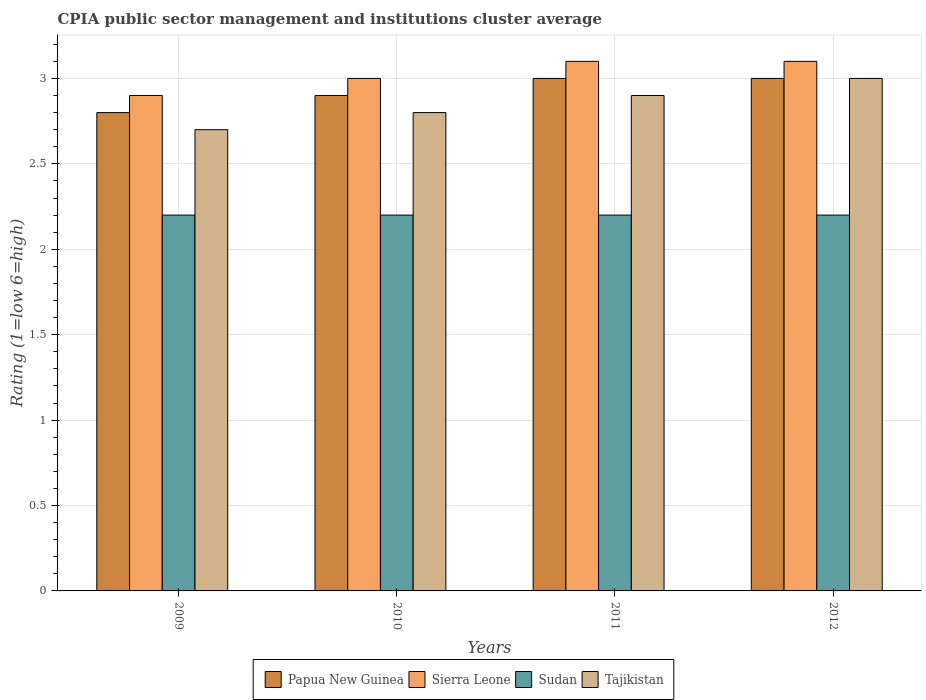Are the number of bars per tick equal to the number of legend labels?
Your response must be concise. Yes. Are the number of bars on each tick of the X-axis equal?
Give a very brief answer. Yes. How many bars are there on the 4th tick from the right?
Your answer should be compact. 4. In how many cases, is the number of bars for a given year not equal to the number of legend labels?
Your answer should be compact. 0. What is the CPIA rating in Sierra Leone in 2012?
Provide a short and direct response. 3.1. Across all years, what is the maximum CPIA rating in Papua New Guinea?
Provide a short and direct response. 3. What is the total CPIA rating in Tajikistan in the graph?
Give a very brief answer. 11.4. What is the difference between the CPIA rating in Sierra Leone in 2010 and that in 2012?
Offer a terse response. -0.1. What is the difference between the CPIA rating in Sierra Leone in 2010 and the CPIA rating in Sudan in 2012?
Provide a succinct answer. 0.8. What is the average CPIA rating in Sudan per year?
Offer a very short reply. 2.2. In the year 2011, what is the difference between the CPIA rating in Sierra Leone and CPIA rating in Tajikistan?
Provide a succinct answer. 0.2. In how many years, is the CPIA rating in Papua New Guinea greater than 2.9?
Your response must be concise. 2. Is the CPIA rating in Sudan in 2010 less than that in 2011?
Make the answer very short. No. What is the difference between the highest and the second highest CPIA rating in Tajikistan?
Offer a very short reply. 0.1. What is the difference between the highest and the lowest CPIA rating in Papua New Guinea?
Keep it short and to the point. 0.2. Is it the case that in every year, the sum of the CPIA rating in Sierra Leone and CPIA rating in Papua New Guinea is greater than the sum of CPIA rating in Tajikistan and CPIA rating in Sudan?
Offer a very short reply. No. What does the 2nd bar from the left in 2010 represents?
Offer a very short reply. Sierra Leone. What does the 3rd bar from the right in 2009 represents?
Give a very brief answer. Sierra Leone. How many bars are there?
Your answer should be very brief. 16. Are all the bars in the graph horizontal?
Your answer should be very brief. No. What is the difference between two consecutive major ticks on the Y-axis?
Your answer should be very brief. 0.5. Are the values on the major ticks of Y-axis written in scientific E-notation?
Your answer should be very brief. No. Does the graph contain any zero values?
Offer a terse response. No. Does the graph contain grids?
Provide a succinct answer. Yes. Where does the legend appear in the graph?
Your answer should be compact. Bottom center. How many legend labels are there?
Provide a short and direct response. 4. How are the legend labels stacked?
Keep it short and to the point. Horizontal. What is the title of the graph?
Provide a succinct answer. CPIA public sector management and institutions cluster average. Does "Germany" appear as one of the legend labels in the graph?
Ensure brevity in your answer.  No. What is the label or title of the X-axis?
Your answer should be compact. Years. What is the Rating (1=low 6=high) of Papua New Guinea in 2009?
Give a very brief answer. 2.8. What is the Rating (1=low 6=high) of Sierra Leone in 2009?
Make the answer very short. 2.9. What is the Rating (1=low 6=high) in Sudan in 2009?
Provide a succinct answer. 2.2. What is the Rating (1=low 6=high) in Tajikistan in 2009?
Ensure brevity in your answer.  2.7. What is the Rating (1=low 6=high) of Sierra Leone in 2010?
Offer a very short reply. 3. What is the Rating (1=low 6=high) in Tajikistan in 2010?
Ensure brevity in your answer.  2.8. What is the Rating (1=low 6=high) in Papua New Guinea in 2011?
Keep it short and to the point. 3. What is the Rating (1=low 6=high) in Sudan in 2011?
Provide a succinct answer. 2.2. What is the Rating (1=low 6=high) in Tajikistan in 2011?
Keep it short and to the point. 2.9. What is the Rating (1=low 6=high) of Papua New Guinea in 2012?
Your response must be concise. 3. What is the Rating (1=low 6=high) in Sudan in 2012?
Provide a short and direct response. 2.2. What is the Rating (1=low 6=high) in Tajikistan in 2012?
Your answer should be compact. 3. Across all years, what is the maximum Rating (1=low 6=high) in Papua New Guinea?
Ensure brevity in your answer.  3. Across all years, what is the maximum Rating (1=low 6=high) in Sierra Leone?
Provide a short and direct response. 3.1. Across all years, what is the minimum Rating (1=low 6=high) of Sudan?
Your answer should be compact. 2.2. Across all years, what is the minimum Rating (1=low 6=high) in Tajikistan?
Ensure brevity in your answer.  2.7. What is the total Rating (1=low 6=high) of Papua New Guinea in the graph?
Provide a succinct answer. 11.7. What is the total Rating (1=low 6=high) of Tajikistan in the graph?
Your response must be concise. 11.4. What is the difference between the Rating (1=low 6=high) in Sierra Leone in 2009 and that in 2011?
Your response must be concise. -0.2. What is the difference between the Rating (1=low 6=high) of Sudan in 2009 and that in 2011?
Offer a very short reply. 0. What is the difference between the Rating (1=low 6=high) in Tajikistan in 2009 and that in 2011?
Provide a short and direct response. -0.2. What is the difference between the Rating (1=low 6=high) of Papua New Guinea in 2009 and that in 2012?
Ensure brevity in your answer.  -0.2. What is the difference between the Rating (1=low 6=high) of Sudan in 2010 and that in 2011?
Make the answer very short. 0. What is the difference between the Rating (1=low 6=high) in Tajikistan in 2010 and that in 2011?
Your answer should be very brief. -0.1. What is the difference between the Rating (1=low 6=high) in Papua New Guinea in 2010 and that in 2012?
Provide a succinct answer. -0.1. What is the difference between the Rating (1=low 6=high) in Sierra Leone in 2010 and that in 2012?
Provide a succinct answer. -0.1. What is the difference between the Rating (1=low 6=high) of Sudan in 2010 and that in 2012?
Give a very brief answer. 0. What is the difference between the Rating (1=low 6=high) in Tajikistan in 2010 and that in 2012?
Make the answer very short. -0.2. What is the difference between the Rating (1=low 6=high) of Sierra Leone in 2011 and that in 2012?
Your answer should be compact. 0. What is the difference between the Rating (1=low 6=high) of Sudan in 2011 and that in 2012?
Offer a very short reply. 0. What is the difference between the Rating (1=low 6=high) in Tajikistan in 2011 and that in 2012?
Your answer should be compact. -0.1. What is the difference between the Rating (1=low 6=high) in Papua New Guinea in 2009 and the Rating (1=low 6=high) in Sierra Leone in 2010?
Offer a very short reply. -0.2. What is the difference between the Rating (1=low 6=high) of Papua New Guinea in 2009 and the Rating (1=low 6=high) of Sudan in 2010?
Make the answer very short. 0.6. What is the difference between the Rating (1=low 6=high) of Papua New Guinea in 2009 and the Rating (1=low 6=high) of Tajikistan in 2010?
Ensure brevity in your answer.  0. What is the difference between the Rating (1=low 6=high) of Sierra Leone in 2009 and the Rating (1=low 6=high) of Sudan in 2010?
Keep it short and to the point. 0.7. What is the difference between the Rating (1=low 6=high) in Papua New Guinea in 2009 and the Rating (1=low 6=high) in Sierra Leone in 2011?
Offer a very short reply. -0.3. What is the difference between the Rating (1=low 6=high) of Papua New Guinea in 2009 and the Rating (1=low 6=high) of Sudan in 2011?
Offer a terse response. 0.6. What is the difference between the Rating (1=low 6=high) in Sudan in 2009 and the Rating (1=low 6=high) in Tajikistan in 2011?
Your response must be concise. -0.7. What is the difference between the Rating (1=low 6=high) of Papua New Guinea in 2009 and the Rating (1=low 6=high) of Sierra Leone in 2012?
Your answer should be very brief. -0.3. What is the difference between the Rating (1=low 6=high) in Papua New Guinea in 2009 and the Rating (1=low 6=high) in Sudan in 2012?
Your response must be concise. 0.6. What is the difference between the Rating (1=low 6=high) of Sierra Leone in 2009 and the Rating (1=low 6=high) of Tajikistan in 2012?
Your answer should be compact. -0.1. What is the difference between the Rating (1=low 6=high) of Sudan in 2009 and the Rating (1=low 6=high) of Tajikistan in 2012?
Ensure brevity in your answer.  -0.8. What is the difference between the Rating (1=low 6=high) in Papua New Guinea in 2010 and the Rating (1=low 6=high) in Sierra Leone in 2011?
Make the answer very short. -0.2. What is the difference between the Rating (1=low 6=high) in Papua New Guinea in 2010 and the Rating (1=low 6=high) in Sudan in 2011?
Ensure brevity in your answer.  0.7. What is the difference between the Rating (1=low 6=high) in Papua New Guinea in 2010 and the Rating (1=low 6=high) in Tajikistan in 2011?
Your response must be concise. 0. What is the difference between the Rating (1=low 6=high) of Sudan in 2010 and the Rating (1=low 6=high) of Tajikistan in 2011?
Your response must be concise. -0.7. What is the difference between the Rating (1=low 6=high) of Papua New Guinea in 2010 and the Rating (1=low 6=high) of Tajikistan in 2012?
Make the answer very short. -0.1. What is the difference between the Rating (1=low 6=high) of Sierra Leone in 2010 and the Rating (1=low 6=high) of Tajikistan in 2012?
Ensure brevity in your answer.  0. What is the difference between the Rating (1=low 6=high) in Sierra Leone in 2011 and the Rating (1=low 6=high) in Sudan in 2012?
Provide a succinct answer. 0.9. What is the average Rating (1=low 6=high) in Papua New Guinea per year?
Ensure brevity in your answer.  2.92. What is the average Rating (1=low 6=high) in Sierra Leone per year?
Offer a very short reply. 3.02. What is the average Rating (1=low 6=high) of Sudan per year?
Provide a succinct answer. 2.2. What is the average Rating (1=low 6=high) in Tajikistan per year?
Give a very brief answer. 2.85. In the year 2009, what is the difference between the Rating (1=low 6=high) of Papua New Guinea and Rating (1=low 6=high) of Sierra Leone?
Your response must be concise. -0.1. In the year 2009, what is the difference between the Rating (1=low 6=high) in Papua New Guinea and Rating (1=low 6=high) in Sudan?
Make the answer very short. 0.6. In the year 2009, what is the difference between the Rating (1=low 6=high) of Sierra Leone and Rating (1=low 6=high) of Sudan?
Your answer should be very brief. 0.7. In the year 2009, what is the difference between the Rating (1=low 6=high) in Sierra Leone and Rating (1=low 6=high) in Tajikistan?
Ensure brevity in your answer.  0.2. In the year 2010, what is the difference between the Rating (1=low 6=high) of Papua New Guinea and Rating (1=low 6=high) of Sudan?
Provide a short and direct response. 0.7. In the year 2010, what is the difference between the Rating (1=low 6=high) in Sudan and Rating (1=low 6=high) in Tajikistan?
Ensure brevity in your answer.  -0.6. In the year 2011, what is the difference between the Rating (1=low 6=high) of Sierra Leone and Rating (1=low 6=high) of Sudan?
Your answer should be compact. 0.9. In the year 2011, what is the difference between the Rating (1=low 6=high) of Sierra Leone and Rating (1=low 6=high) of Tajikistan?
Keep it short and to the point. 0.2. In the year 2011, what is the difference between the Rating (1=low 6=high) in Sudan and Rating (1=low 6=high) in Tajikistan?
Make the answer very short. -0.7. In the year 2012, what is the difference between the Rating (1=low 6=high) of Papua New Guinea and Rating (1=low 6=high) of Sudan?
Keep it short and to the point. 0.8. In the year 2012, what is the difference between the Rating (1=low 6=high) of Papua New Guinea and Rating (1=low 6=high) of Tajikistan?
Your response must be concise. 0. In the year 2012, what is the difference between the Rating (1=low 6=high) in Sierra Leone and Rating (1=low 6=high) in Sudan?
Your response must be concise. 0.9. In the year 2012, what is the difference between the Rating (1=low 6=high) of Sudan and Rating (1=low 6=high) of Tajikistan?
Offer a very short reply. -0.8. What is the ratio of the Rating (1=low 6=high) of Papua New Guinea in 2009 to that in 2010?
Give a very brief answer. 0.97. What is the ratio of the Rating (1=low 6=high) in Sierra Leone in 2009 to that in 2010?
Provide a succinct answer. 0.97. What is the ratio of the Rating (1=low 6=high) of Tajikistan in 2009 to that in 2010?
Your answer should be compact. 0.96. What is the ratio of the Rating (1=low 6=high) in Papua New Guinea in 2009 to that in 2011?
Give a very brief answer. 0.93. What is the ratio of the Rating (1=low 6=high) in Sierra Leone in 2009 to that in 2011?
Your answer should be compact. 0.94. What is the ratio of the Rating (1=low 6=high) in Tajikistan in 2009 to that in 2011?
Offer a very short reply. 0.93. What is the ratio of the Rating (1=low 6=high) in Papua New Guinea in 2009 to that in 2012?
Provide a succinct answer. 0.93. What is the ratio of the Rating (1=low 6=high) of Sierra Leone in 2009 to that in 2012?
Offer a terse response. 0.94. What is the ratio of the Rating (1=low 6=high) of Tajikistan in 2009 to that in 2012?
Offer a terse response. 0.9. What is the ratio of the Rating (1=low 6=high) of Papua New Guinea in 2010 to that in 2011?
Ensure brevity in your answer.  0.97. What is the ratio of the Rating (1=low 6=high) of Sierra Leone in 2010 to that in 2011?
Offer a terse response. 0.97. What is the ratio of the Rating (1=low 6=high) of Sudan in 2010 to that in 2011?
Give a very brief answer. 1. What is the ratio of the Rating (1=low 6=high) of Tajikistan in 2010 to that in 2011?
Your answer should be compact. 0.97. What is the ratio of the Rating (1=low 6=high) in Papua New Guinea in 2010 to that in 2012?
Keep it short and to the point. 0.97. What is the ratio of the Rating (1=low 6=high) of Tajikistan in 2010 to that in 2012?
Provide a succinct answer. 0.93. What is the ratio of the Rating (1=low 6=high) of Sierra Leone in 2011 to that in 2012?
Your response must be concise. 1. What is the ratio of the Rating (1=low 6=high) in Sudan in 2011 to that in 2012?
Make the answer very short. 1. What is the ratio of the Rating (1=low 6=high) in Tajikistan in 2011 to that in 2012?
Give a very brief answer. 0.97. What is the difference between the highest and the second highest Rating (1=low 6=high) of Sierra Leone?
Make the answer very short. 0. What is the difference between the highest and the second highest Rating (1=low 6=high) of Tajikistan?
Ensure brevity in your answer.  0.1. What is the difference between the highest and the lowest Rating (1=low 6=high) in Papua New Guinea?
Provide a short and direct response. 0.2. What is the difference between the highest and the lowest Rating (1=low 6=high) in Sudan?
Provide a short and direct response. 0. What is the difference between the highest and the lowest Rating (1=low 6=high) in Tajikistan?
Provide a succinct answer. 0.3. 